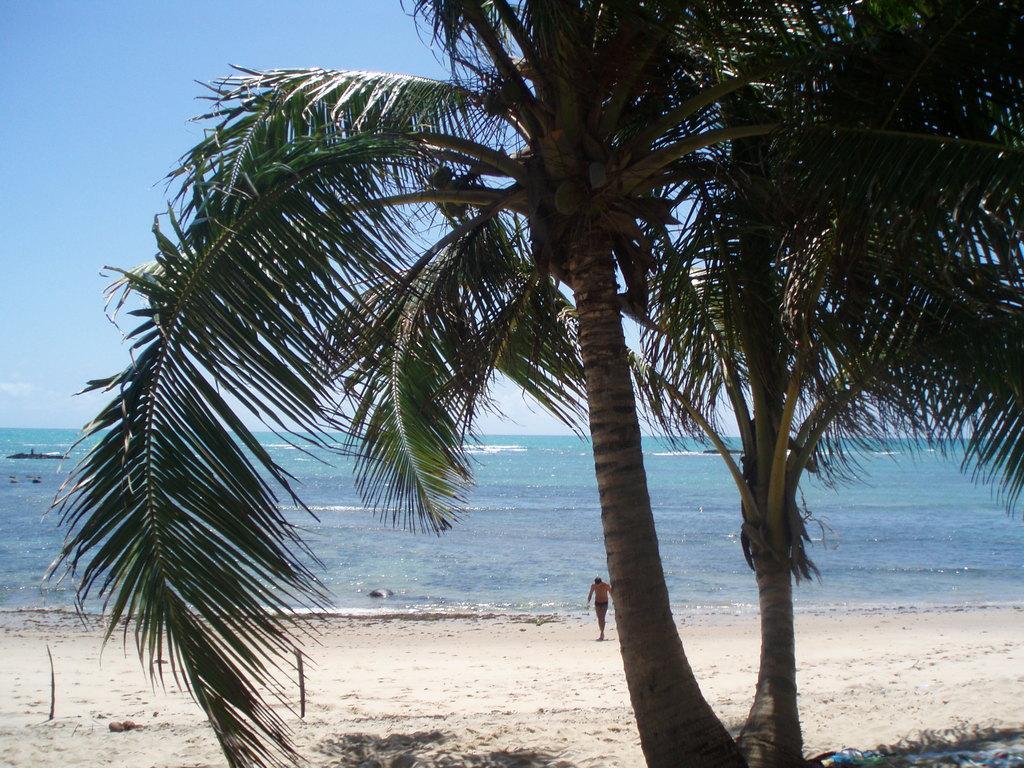Describe this image in one or two sentences. In this image we can see trees, a person on the ground, there are water and the sky in the background. 